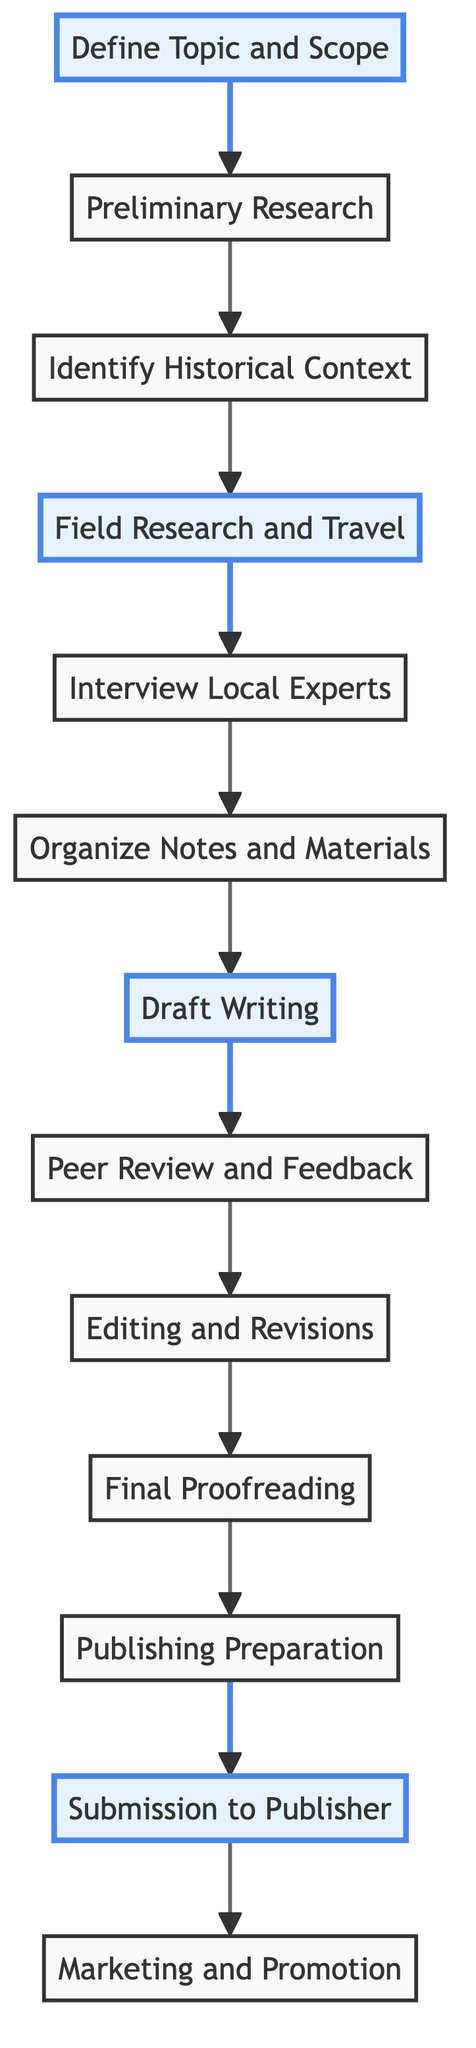What is the first step in the editorial workflow? The first step is labeled as "Define Topic and Scope," which indicates the starting point of the workflow for establishing the regions and historical periods to be covered.
Answer: Define Topic and Scope How many steps are there in total in the workflow? By counting the nodes in the diagram from start to finish, there are a total of 13 steps in the editorial workflow.
Answer: 13 Which step follows "Draft Writing"? According to the flowchart, "Peer Review and Feedback" directly follows the "Draft Writing" step in the sequence of steps.
Answer: Peer Review and Feedback What is the highlighted step focused on fieldwork? The highlighted step related to fieldwork is "Field Research and Travel," which indicates its importance in the workflow for travel writers.
Answer: Field Research and Travel What is the last step before "Marketing and Promotion"? "Submission to Publisher" is the step that comes directly before "Marketing and Promotion" in the flowchart, indicating a progression towards final dissemination.
Answer: Submission to Publisher Which steps involve gathering information and material? The steps that involve gathering information and material are "Preliminary Research," "Field Research and Travel," and "Interview Local Experts," reflecting the research aspect of the workflow.
Answer: Preliminary Research, Field Research and Travel, Interview Local Experts Explain the relationship between "Peer Review and Feedback" and "Editing and Revisions". "Peer Review and Feedback" provides the necessary input for "Editing and Revisions," with feedback from peers used to refine the draft, showing a critical step in the improvement process.
Answer: Peer Review and Feedback provides input for Editing and Revisions How many highlighted steps are present, and what do they represent? There are four highlighted steps: "Define Topic and Scope," "Field Research and Travel," "Draft Writing," and "Submission to Publisher," which emphasizes crucial phases in the workflow that contribute significantly to the overall process.
Answer: 4 steps 